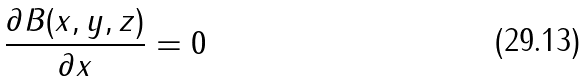<formula> <loc_0><loc_0><loc_500><loc_500>\frac { \partial B ( x , y , z ) } { \partial x } = 0</formula> 